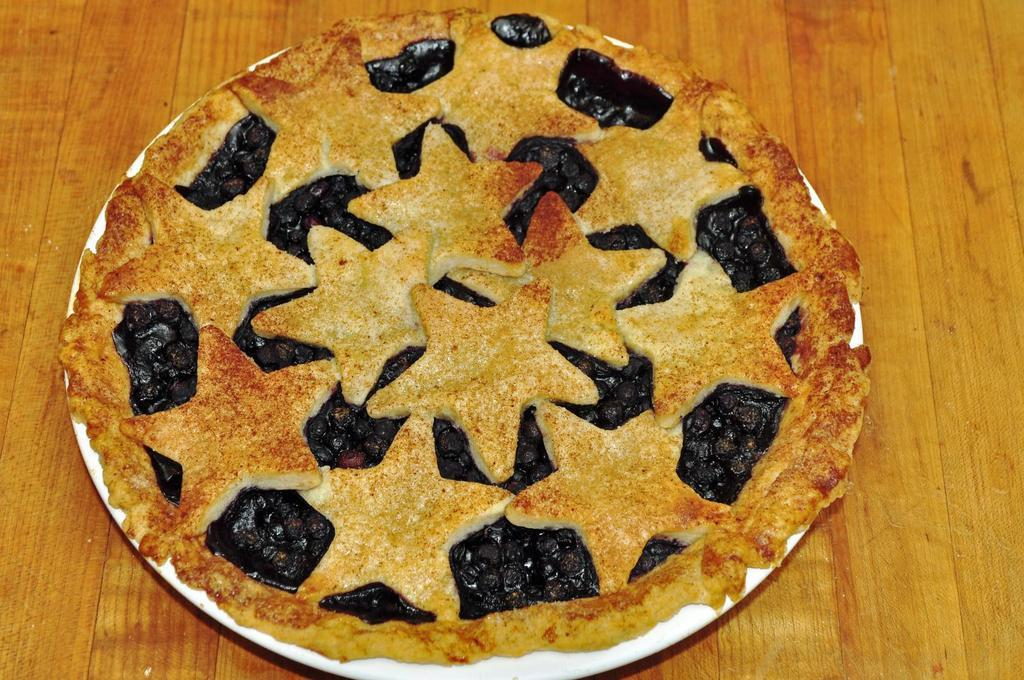What is the main subject of the image? There is a food item in the image. How is the food item presented? The food item is placed on a plate. Where is the plate located? The plate is placed on a table. What type of locket can be seen hanging from the food item in the image? There is no locket present in the image; it features a food item placed on a plate. Can you tell me where the nearest shop is located in the image? There is no shop present in the image; it only shows a food item on a plate. 